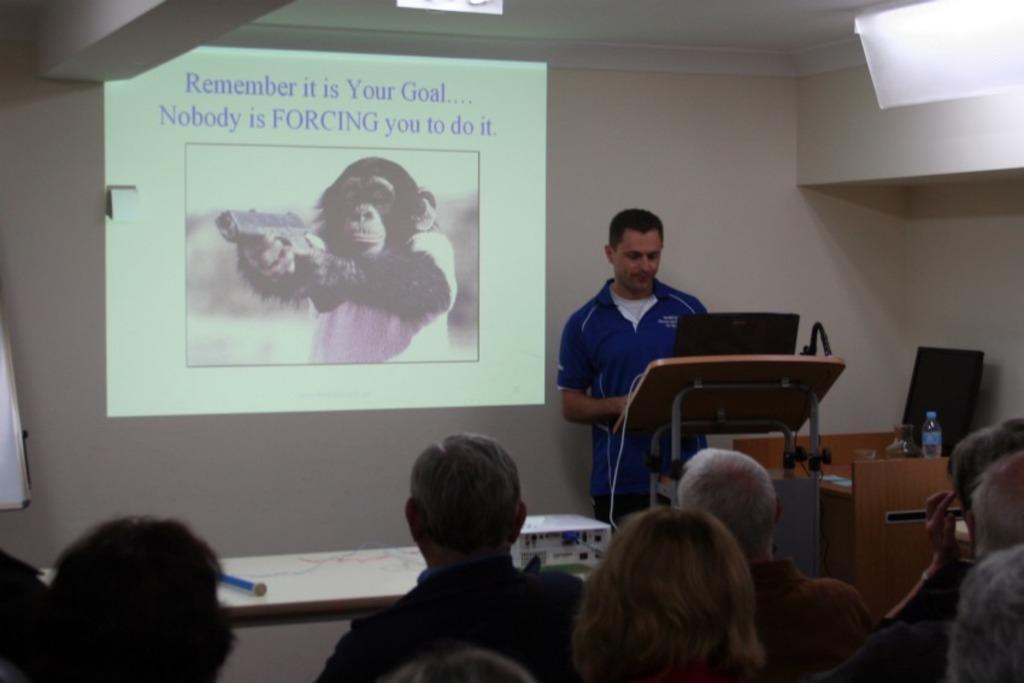Describe this image in one or two sentences. In the center of the image we can see a person standing at the desk with laptop. On the right side of the image there is a monitor and bottle on a table. At the bottom we can see table, projector and persons. In the background there is a wall. 